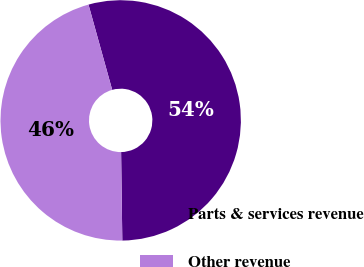<chart> <loc_0><loc_0><loc_500><loc_500><pie_chart><fcel>Parts & services revenue<fcel>Other revenue<nl><fcel>54.1%<fcel>45.9%<nl></chart> 